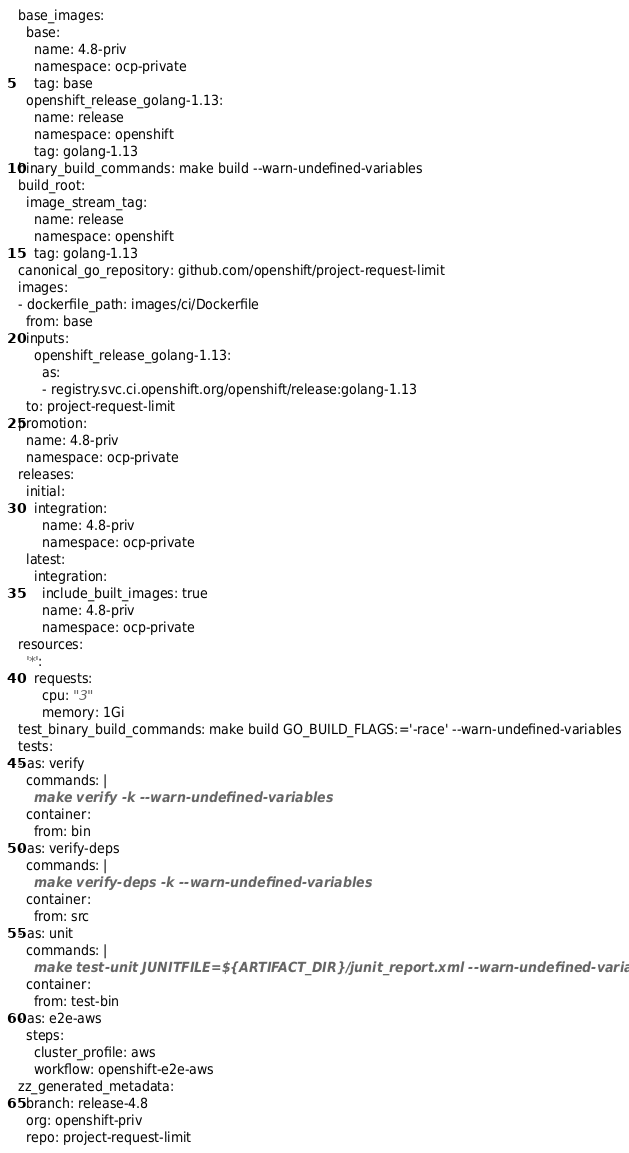Convert code to text. <code><loc_0><loc_0><loc_500><loc_500><_YAML_>base_images:
  base:
    name: 4.8-priv
    namespace: ocp-private
    tag: base
  openshift_release_golang-1.13:
    name: release
    namespace: openshift
    tag: golang-1.13
binary_build_commands: make build --warn-undefined-variables
build_root:
  image_stream_tag:
    name: release
    namespace: openshift
    tag: golang-1.13
canonical_go_repository: github.com/openshift/project-request-limit
images:
- dockerfile_path: images/ci/Dockerfile
  from: base
  inputs:
    openshift_release_golang-1.13:
      as:
      - registry.svc.ci.openshift.org/openshift/release:golang-1.13
  to: project-request-limit
promotion:
  name: 4.8-priv
  namespace: ocp-private
releases:
  initial:
    integration:
      name: 4.8-priv
      namespace: ocp-private
  latest:
    integration:
      include_built_images: true
      name: 4.8-priv
      namespace: ocp-private
resources:
  '*':
    requests:
      cpu: "3"
      memory: 1Gi
test_binary_build_commands: make build GO_BUILD_FLAGS:='-race' --warn-undefined-variables
tests:
- as: verify
  commands: |
    make verify -k --warn-undefined-variables
  container:
    from: bin
- as: verify-deps
  commands: |
    make verify-deps -k --warn-undefined-variables
  container:
    from: src
- as: unit
  commands: |
    make test-unit JUNITFILE=${ARTIFACT_DIR}/junit_report.xml --warn-undefined-variables
  container:
    from: test-bin
- as: e2e-aws
  steps:
    cluster_profile: aws
    workflow: openshift-e2e-aws
zz_generated_metadata:
  branch: release-4.8
  org: openshift-priv
  repo: project-request-limit
</code> 